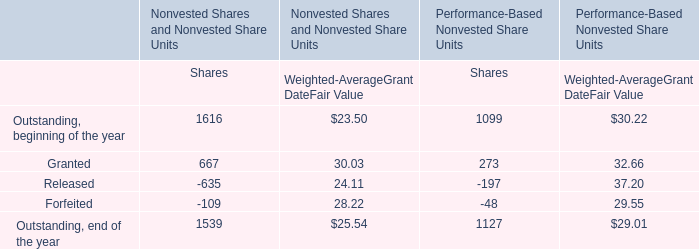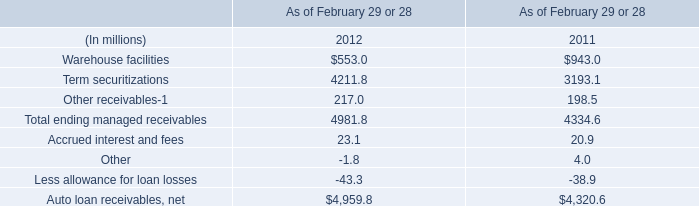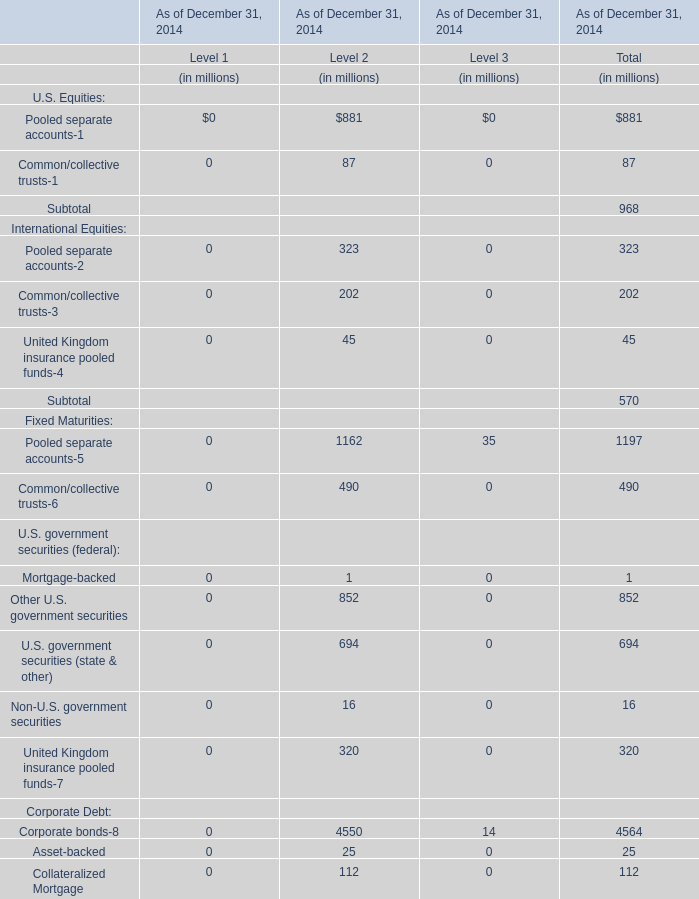What is the average value of Pooled separate accounts-5 for Level 1,Level 2, and Level 3? (in million) 
Computations: ((1162 + 35) / 2)
Answer: 598.5. 